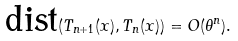<formula> <loc_0><loc_0><loc_500><loc_500>\text {dist} ( T _ { n + 1 } ( x ) , T _ { n } ( x ) ) = O ( \theta ^ { n } ) .</formula> 